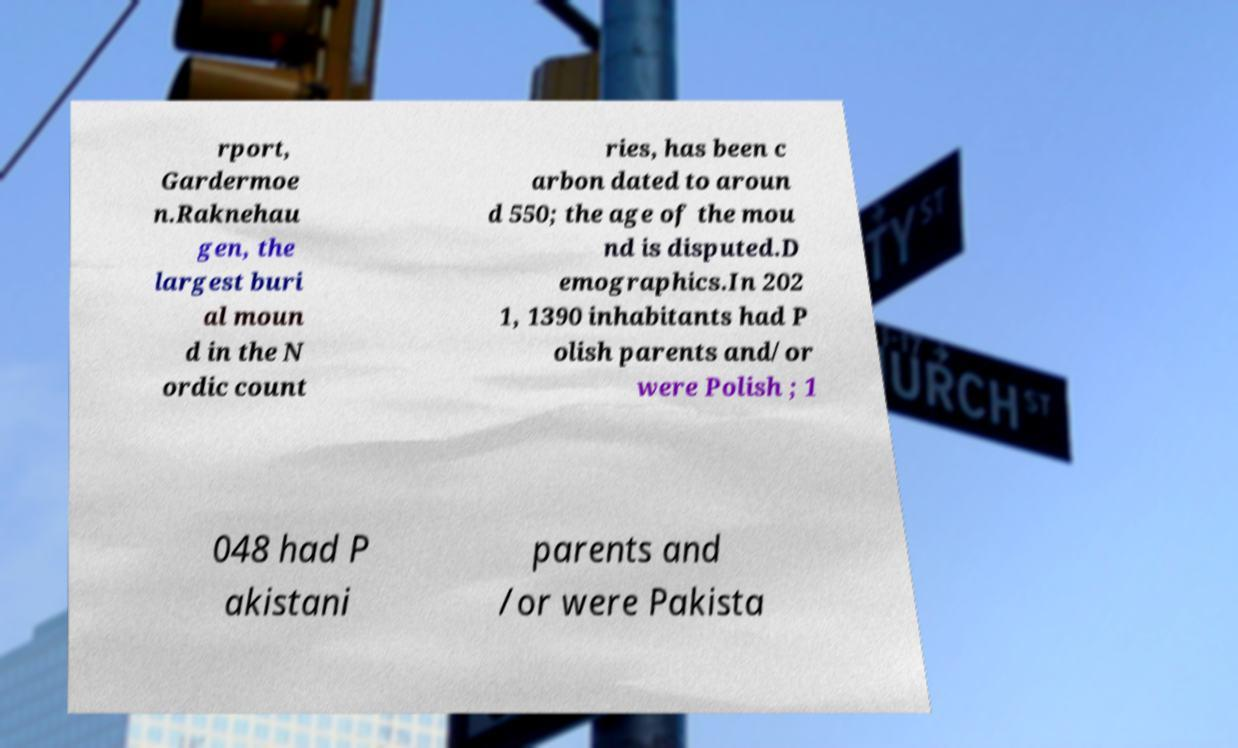I need the written content from this picture converted into text. Can you do that? rport, Gardermoe n.Raknehau gen, the largest buri al moun d in the N ordic count ries, has been c arbon dated to aroun d 550; the age of the mou nd is disputed.D emographics.In 202 1, 1390 inhabitants had P olish parents and/or were Polish ; 1 048 had P akistani parents and /or were Pakista 